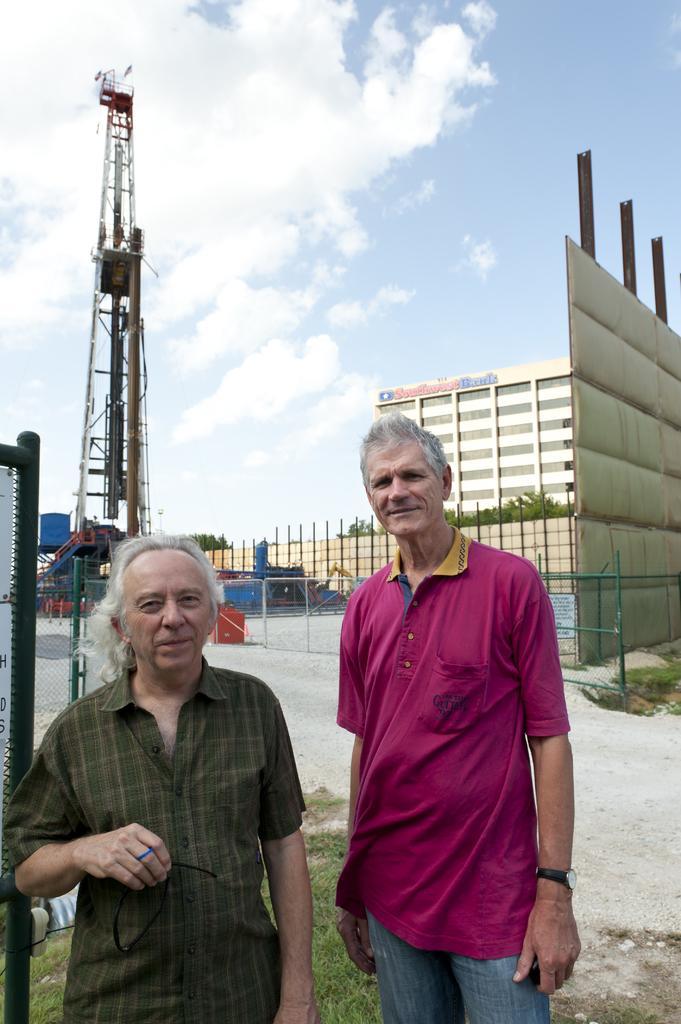Please provide a concise description of this image. In this image there are two persons standing in the bottom of this image. There is a fencing in the background. There is a building on the right side of this image. There is a tower as we can see on the left side of this image. There is a cloudy sky on the top of this image. 